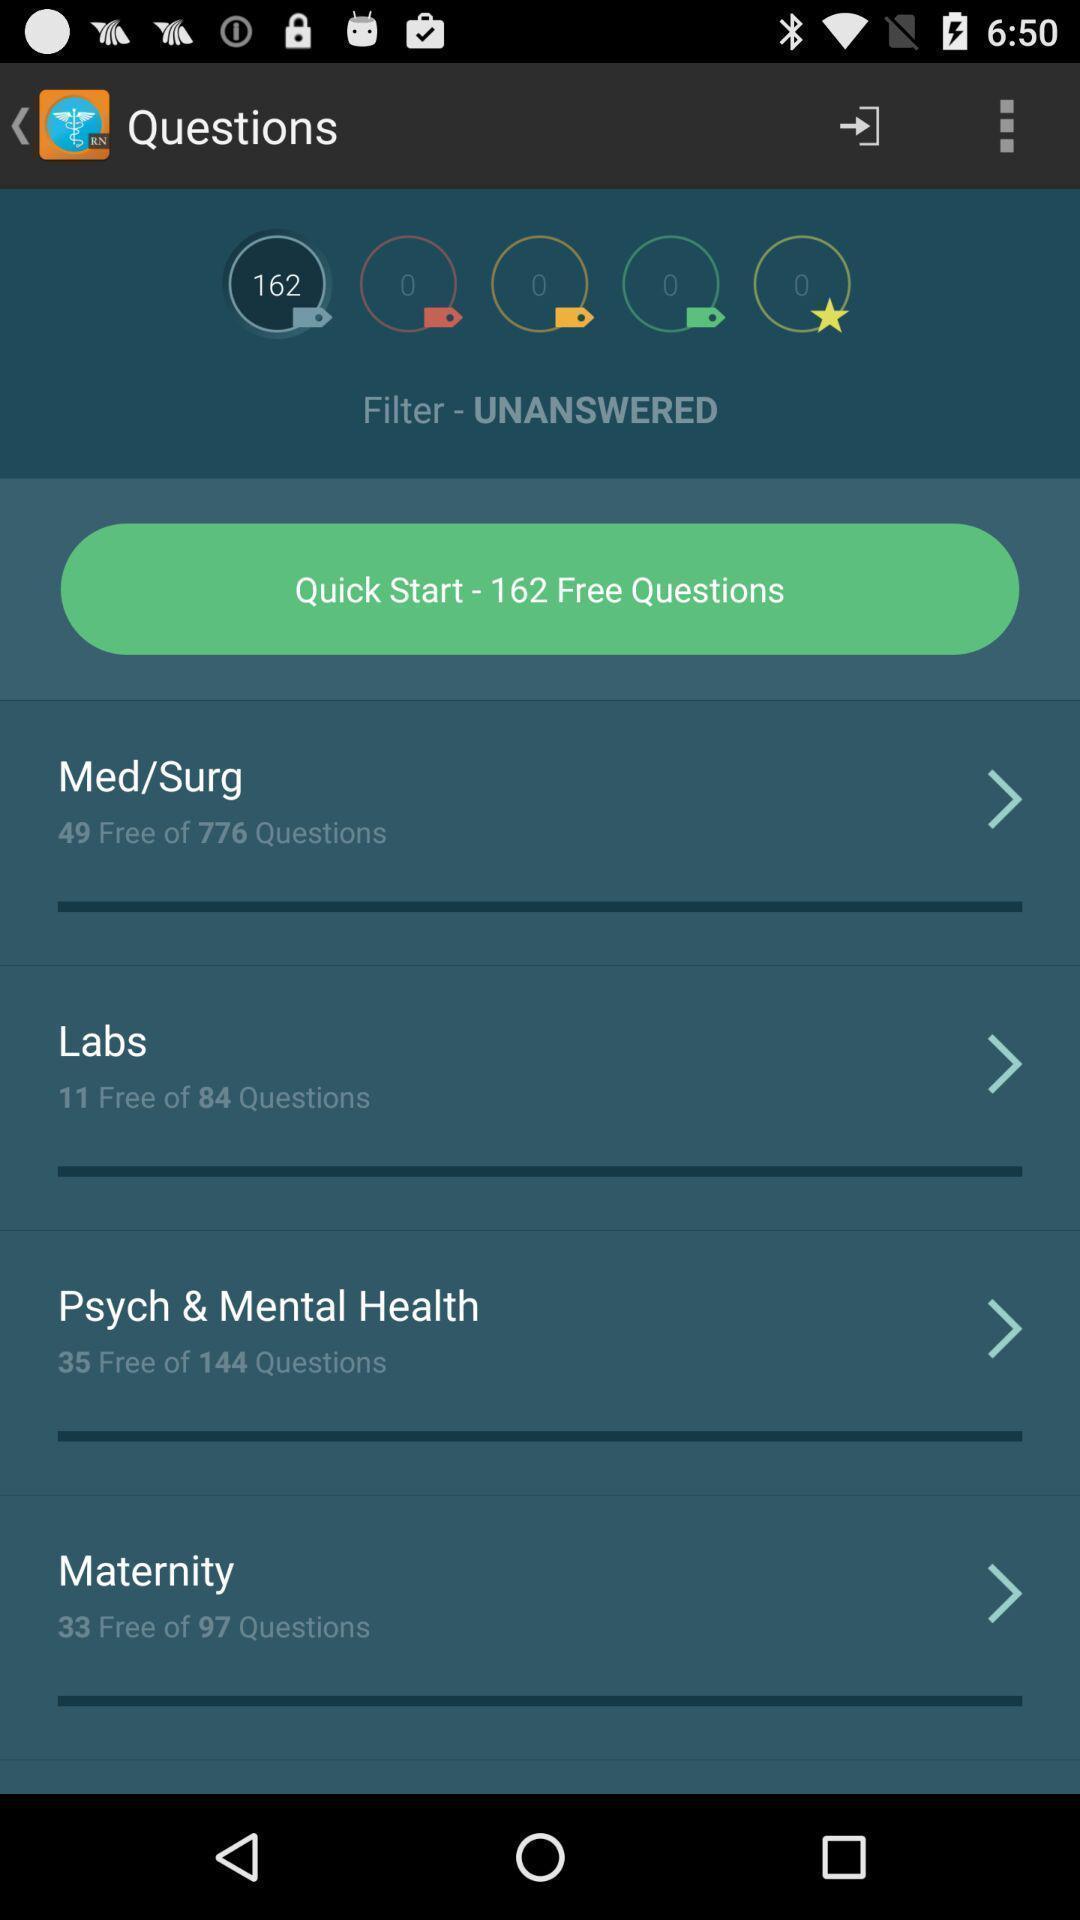Provide a description of this screenshot. Page displaying various questions. 